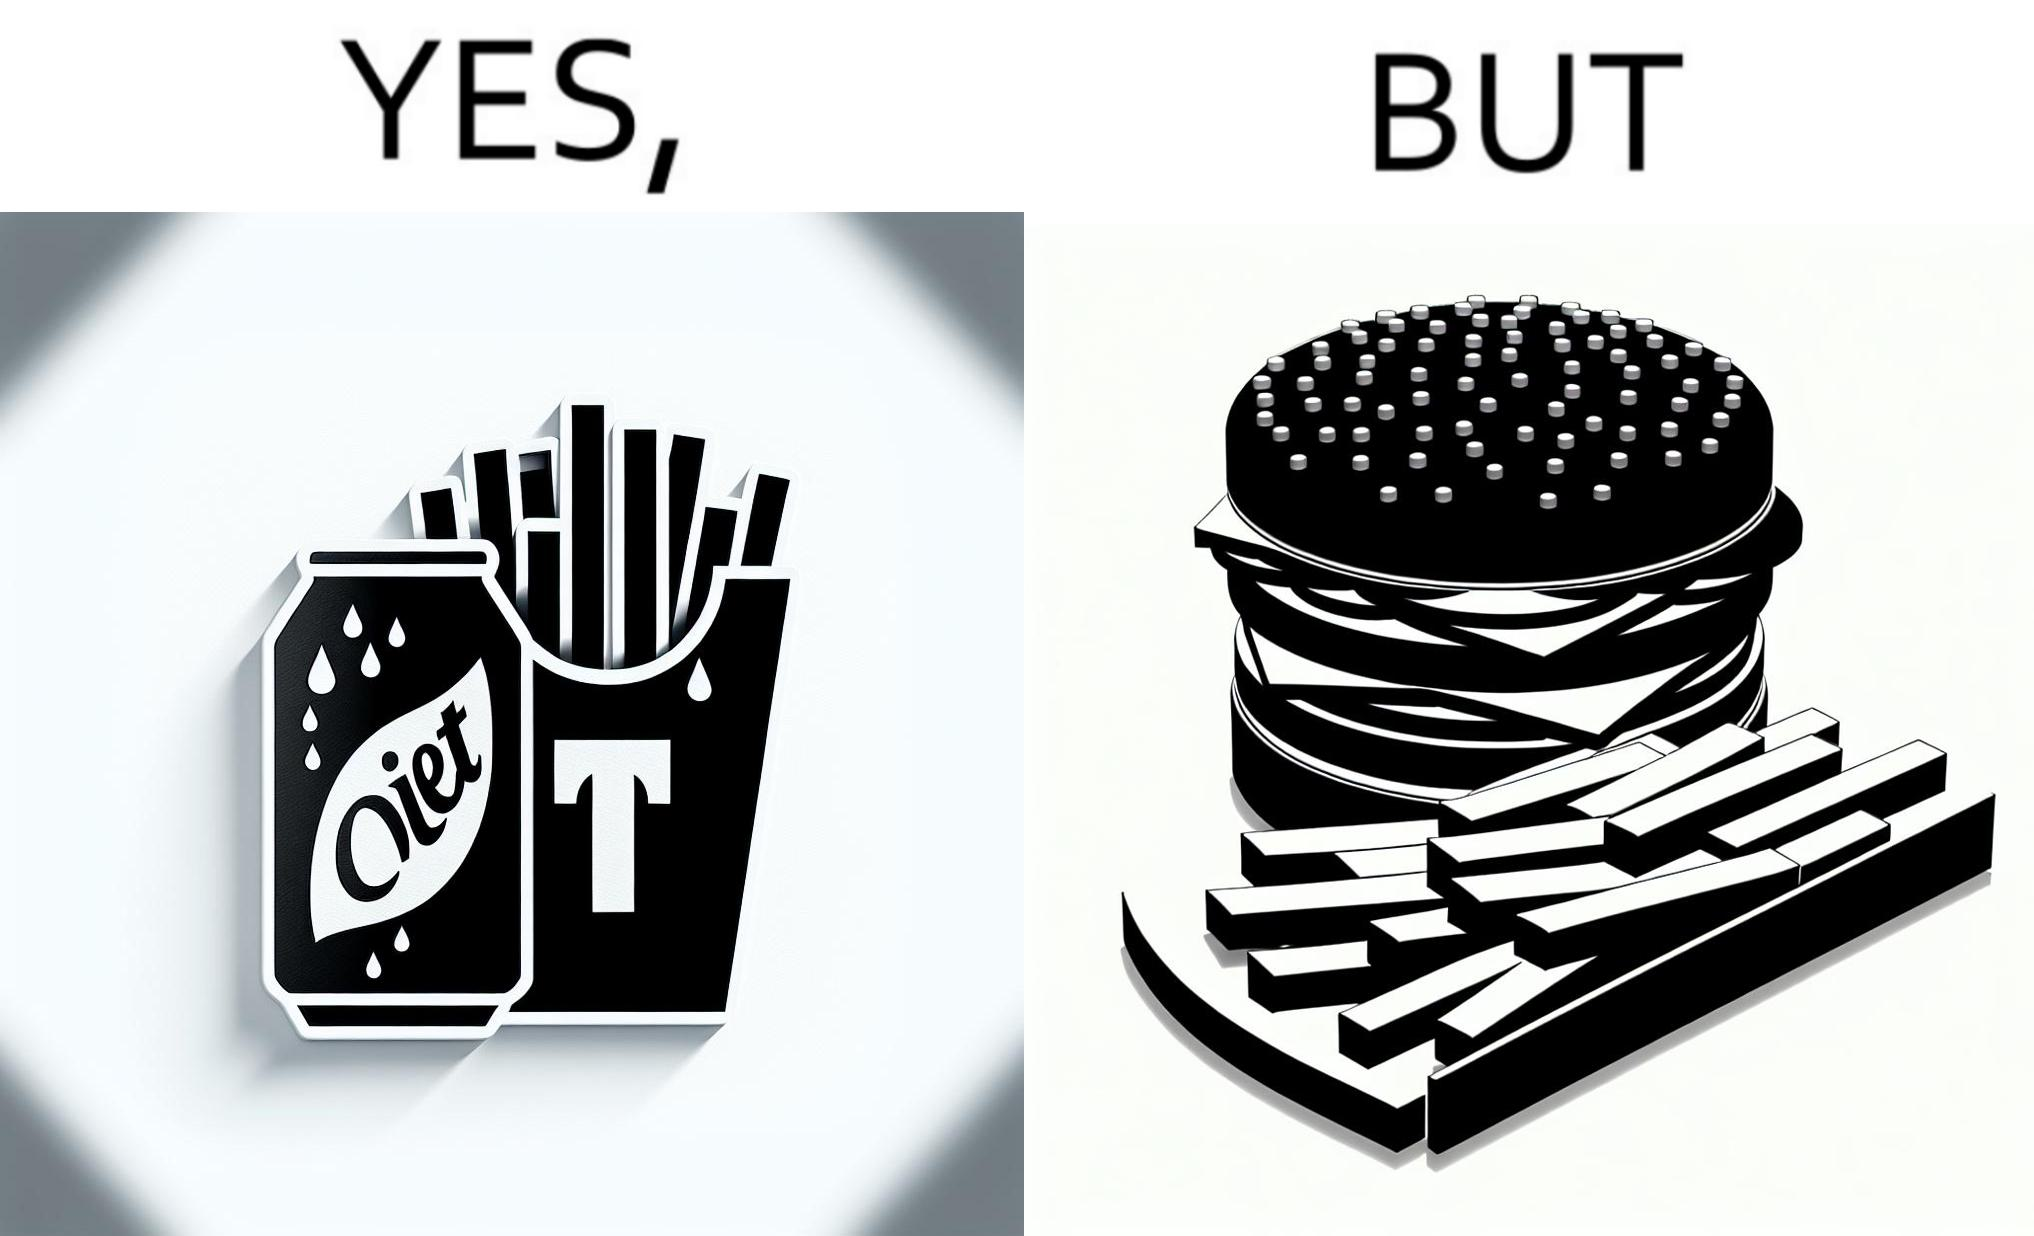What is the satirical meaning behind this image? The image is ironic, because on one hand the person is consuming diet cola suggesting low on sugar as per label meaning the person is health-conscious but on the other hand the same one is having huge size burger with french fries which suggests the person to be health-ignorant 